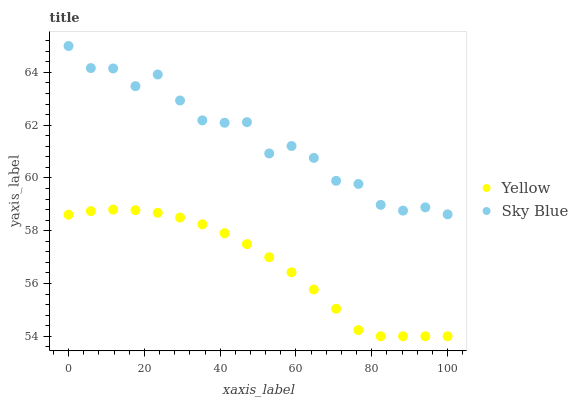Does Yellow have the minimum area under the curve?
Answer yes or no. Yes. Does Sky Blue have the maximum area under the curve?
Answer yes or no. Yes. Does Yellow have the maximum area under the curve?
Answer yes or no. No. Is Yellow the smoothest?
Answer yes or no. Yes. Is Sky Blue the roughest?
Answer yes or no. Yes. Is Yellow the roughest?
Answer yes or no. No. Does Yellow have the lowest value?
Answer yes or no. Yes. Does Sky Blue have the highest value?
Answer yes or no. Yes. Does Yellow have the highest value?
Answer yes or no. No. Is Yellow less than Sky Blue?
Answer yes or no. Yes. Is Sky Blue greater than Yellow?
Answer yes or no. Yes. Does Yellow intersect Sky Blue?
Answer yes or no. No. 